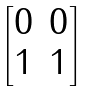Convert formula to latex. <formula><loc_0><loc_0><loc_500><loc_500>\begin{bmatrix} 0 & 0 \\ 1 & 1 \end{bmatrix}</formula> 